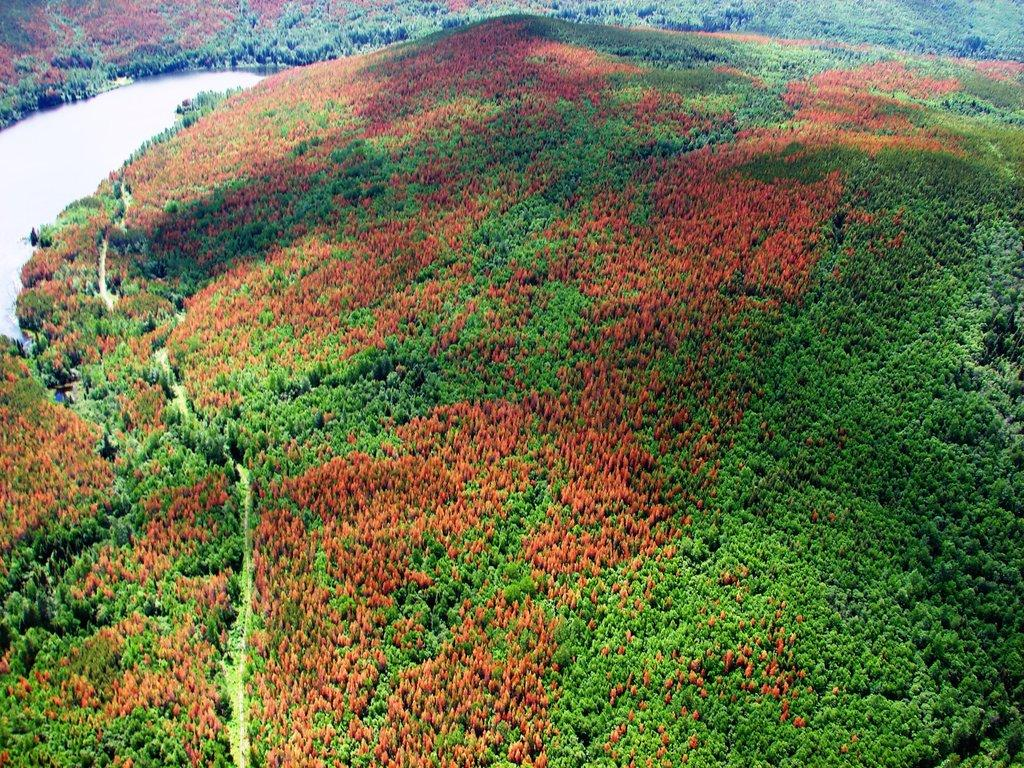What type of vegetation is present in the image? There are trees in the image. What natural element can be seen alongside the trees? There is water visible in the image. What is the behavior of the trees in the image? The behavior of the trees cannot be determined from the image, as trees do not exhibit behavior in the same way that animals or humans do. 